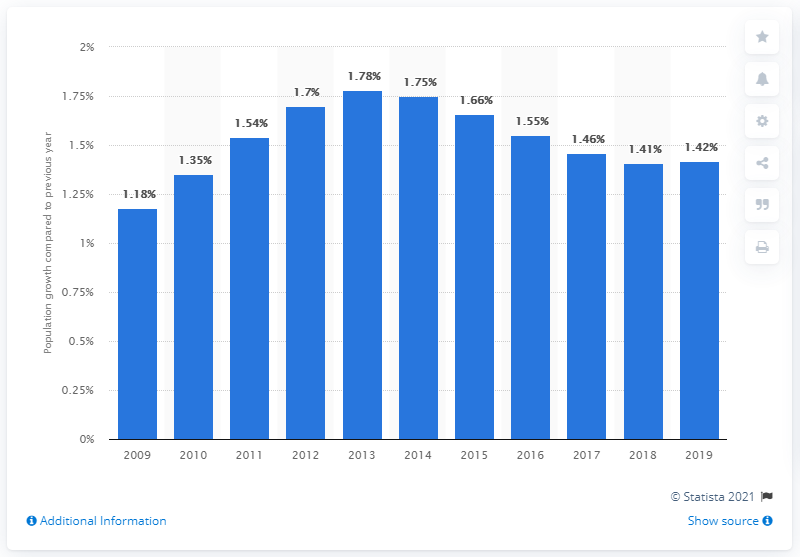Give some essential details in this illustration. According to data released in 2019, the population of Zimbabwe increased by 1.42%. 